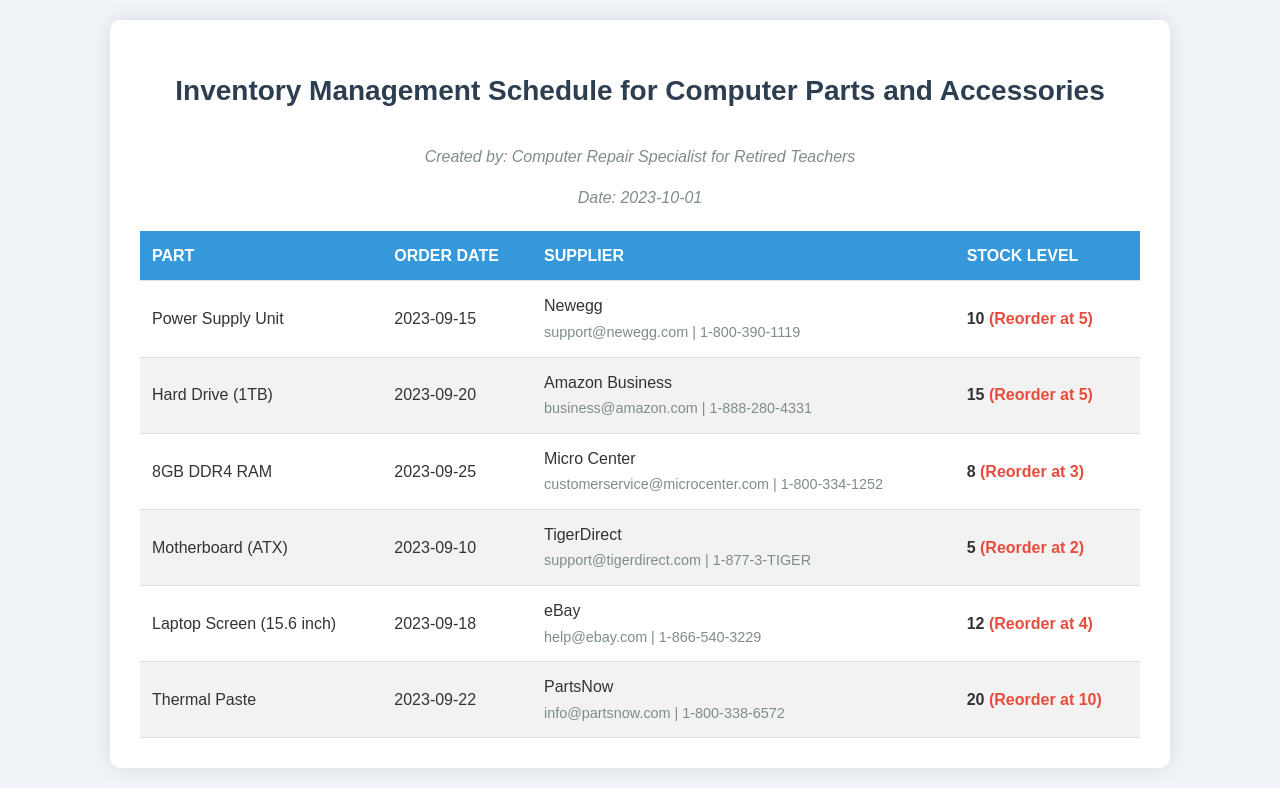What is the order date for the Power Supply Unit? The order date can be found in the schedule under the Power Supply Unit, which shows when the part was ordered.
Answer: 2023-09-15 Which supplier provides the 8GB DDR4 RAM? The supplier information for the 8GB DDR4 RAM indicates which company supplies this part.
Answer: Micro Center What is the stock level of the Hard Drive (1TB)? The stock level for the Hard Drive (1TB) tells us how many units of this part are currently available.
Answer: 15 When was the Motherboard (ATX) ordered? The document states the order date of the Motherboard (ATX), showing when it was last ordered.
Answer: 2023-09-10 How many parts need to be reordered for the Laptop Screen? The reorder level for the Laptop Screen indicates how many parts remain in stock before needing a new order.
Answer: 4 Which part has the lowest stock level? Comparing the stock levels of all parts reveals which one is currently the lowest.
Answer: Motherboard (ATX) How many suppliers are listed in the document? The document features various suppliers providing different parts, which can be counted.
Answer: 6 What stock quantity signals a reorder for the 8GB DDR4 RAM? The reorder level indicates the stock count at which a new order should be placed.
Answer: 3 